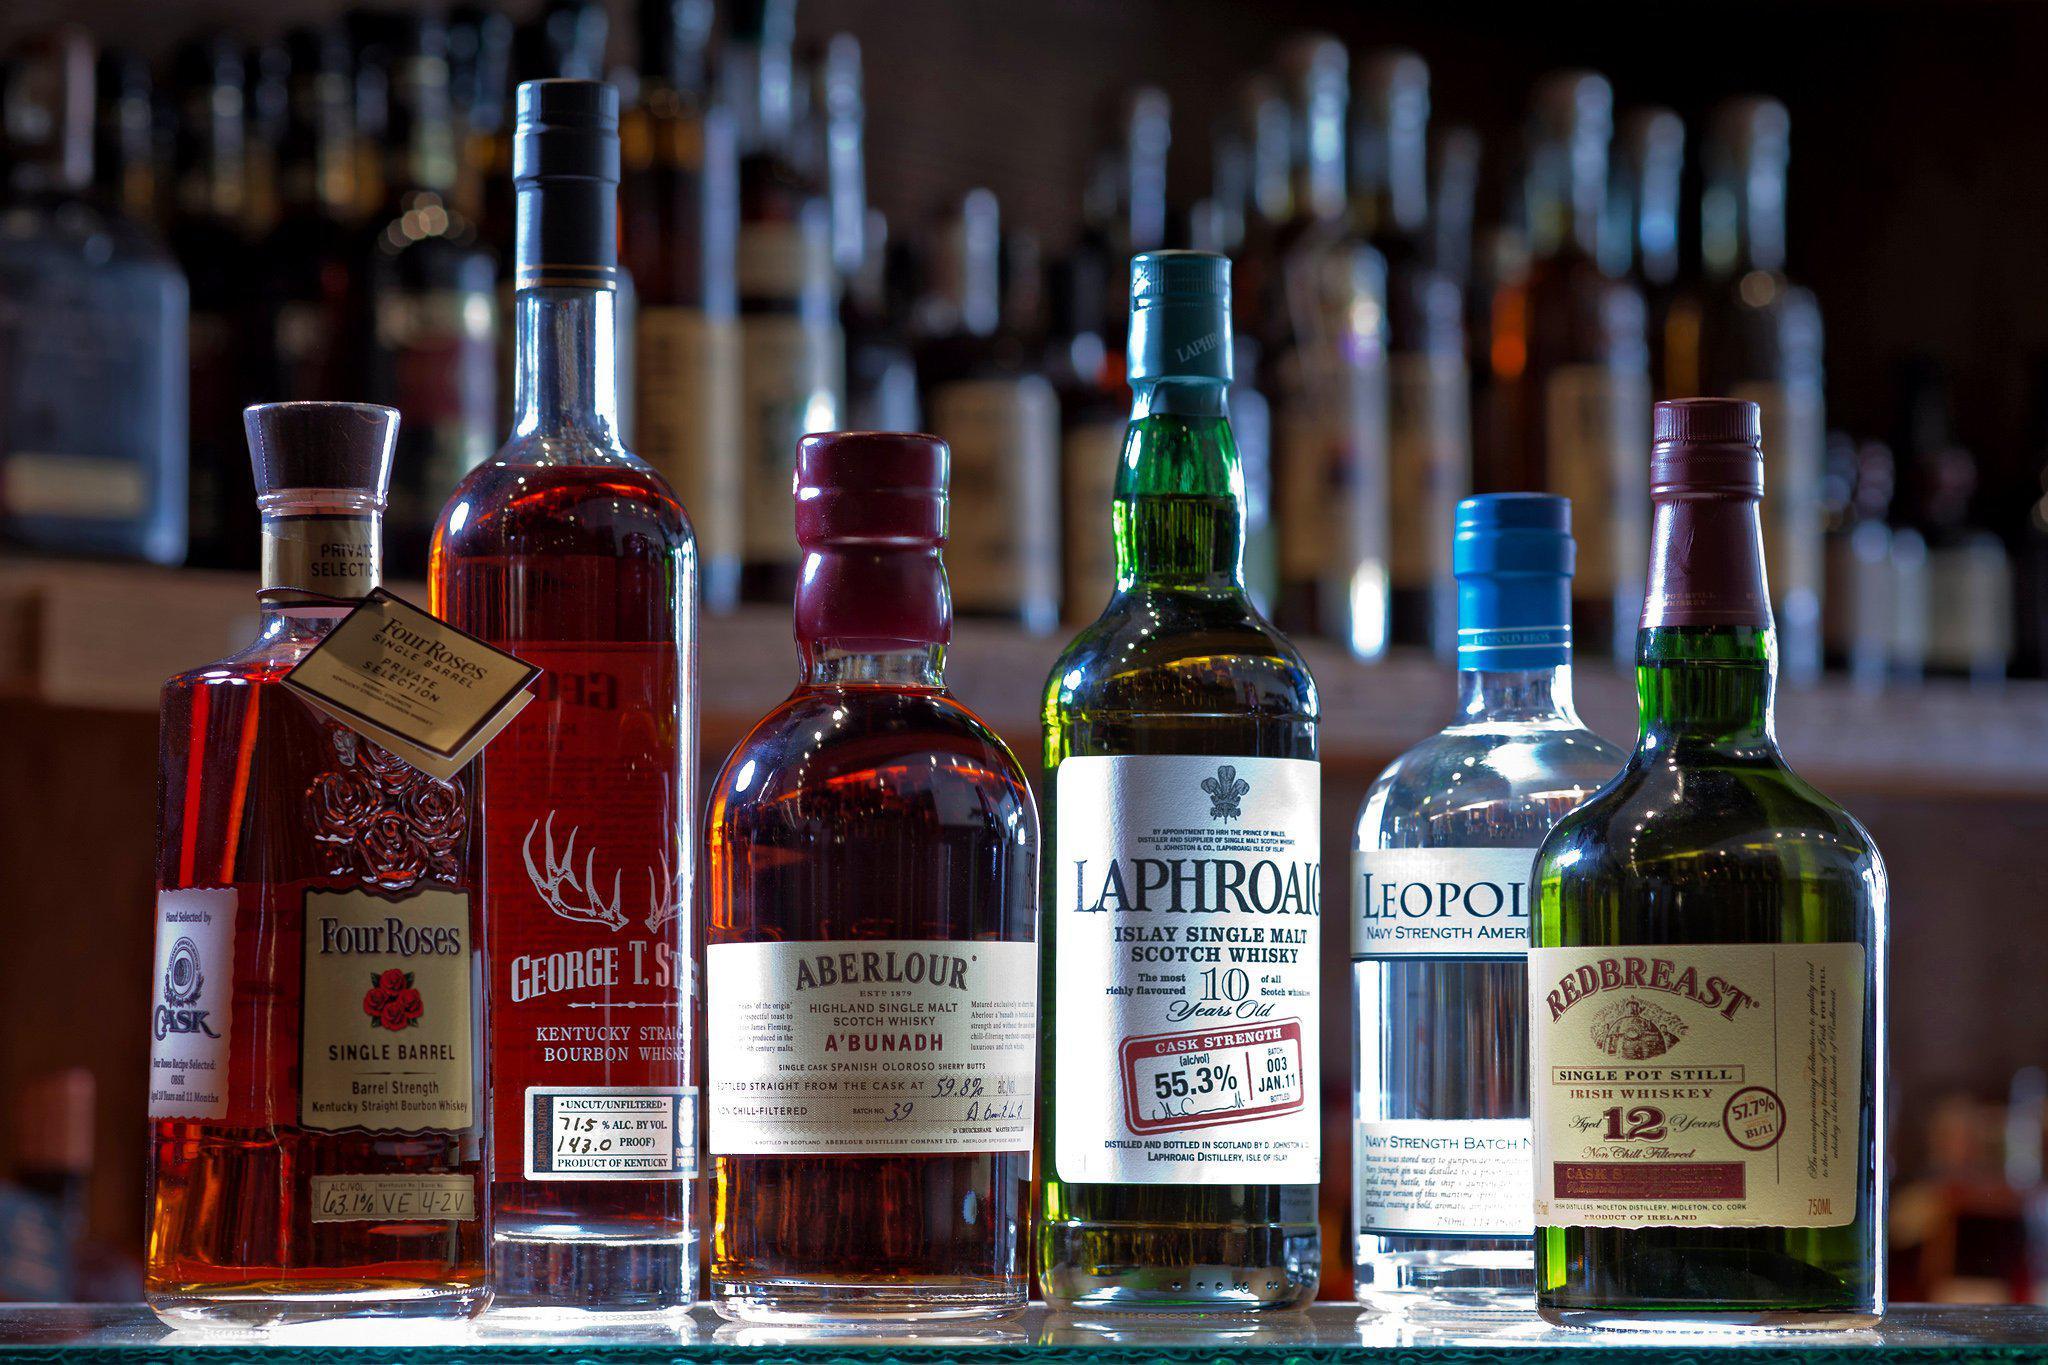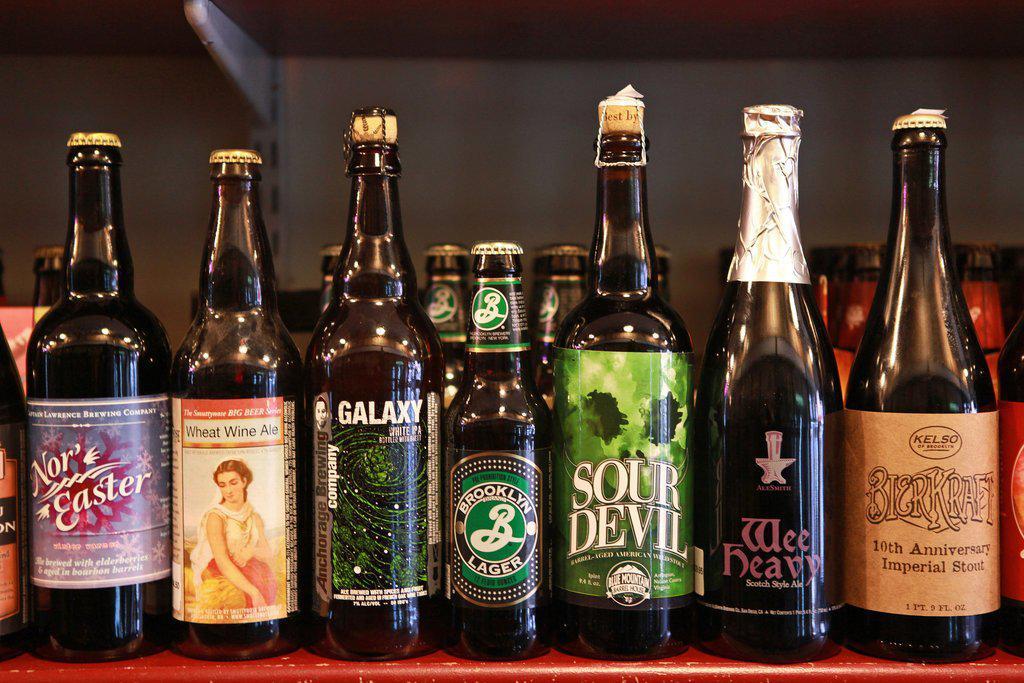The first image is the image on the left, the second image is the image on the right. Examine the images to the left and right. Is the description "A tall glass of beer is shown in only one image." accurate? Answer yes or no. No. 